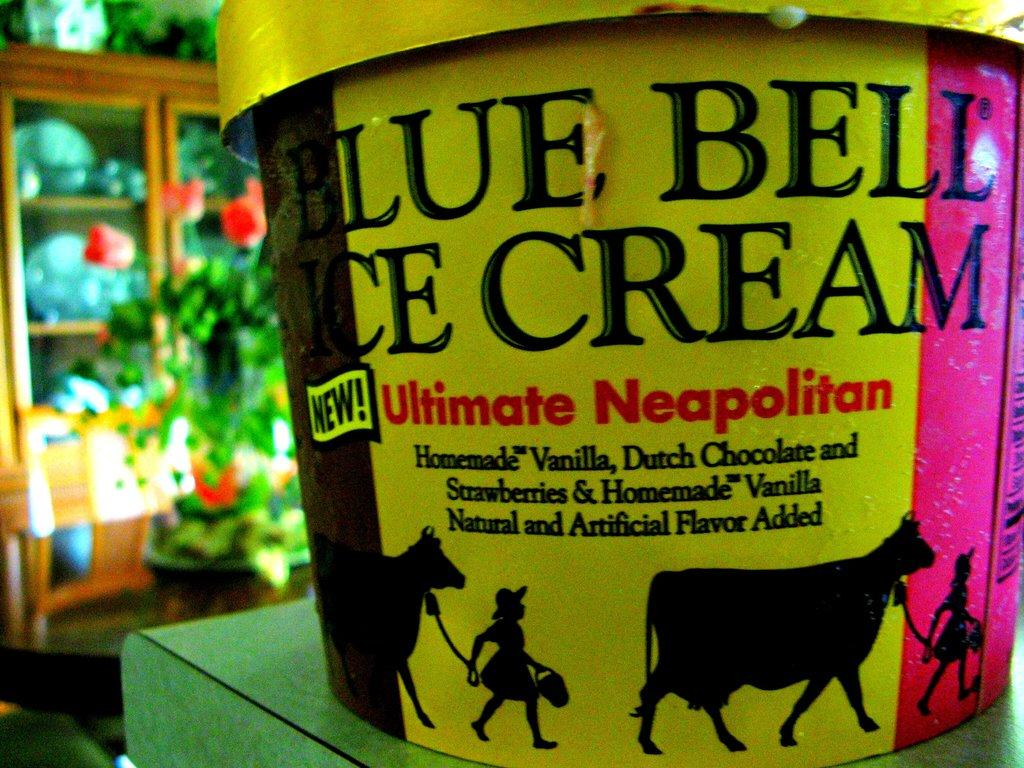What is located in the foreground of the image? There is a bucket in the foreground of the image. What can be seen in the background of the image? There are flower pots and baskets in the background of the image. What type of furniture is visible in the background of the image? There is a cupboard in the background of the image. What is inside the cupboard? There are plates inside the cupboard. What type of stick can be seen holding up the flower pots in the image? There is no stick holding up the flower pots in the image; they are standing on their own. How many roses are visible in the image? There is no rose present in the image. 